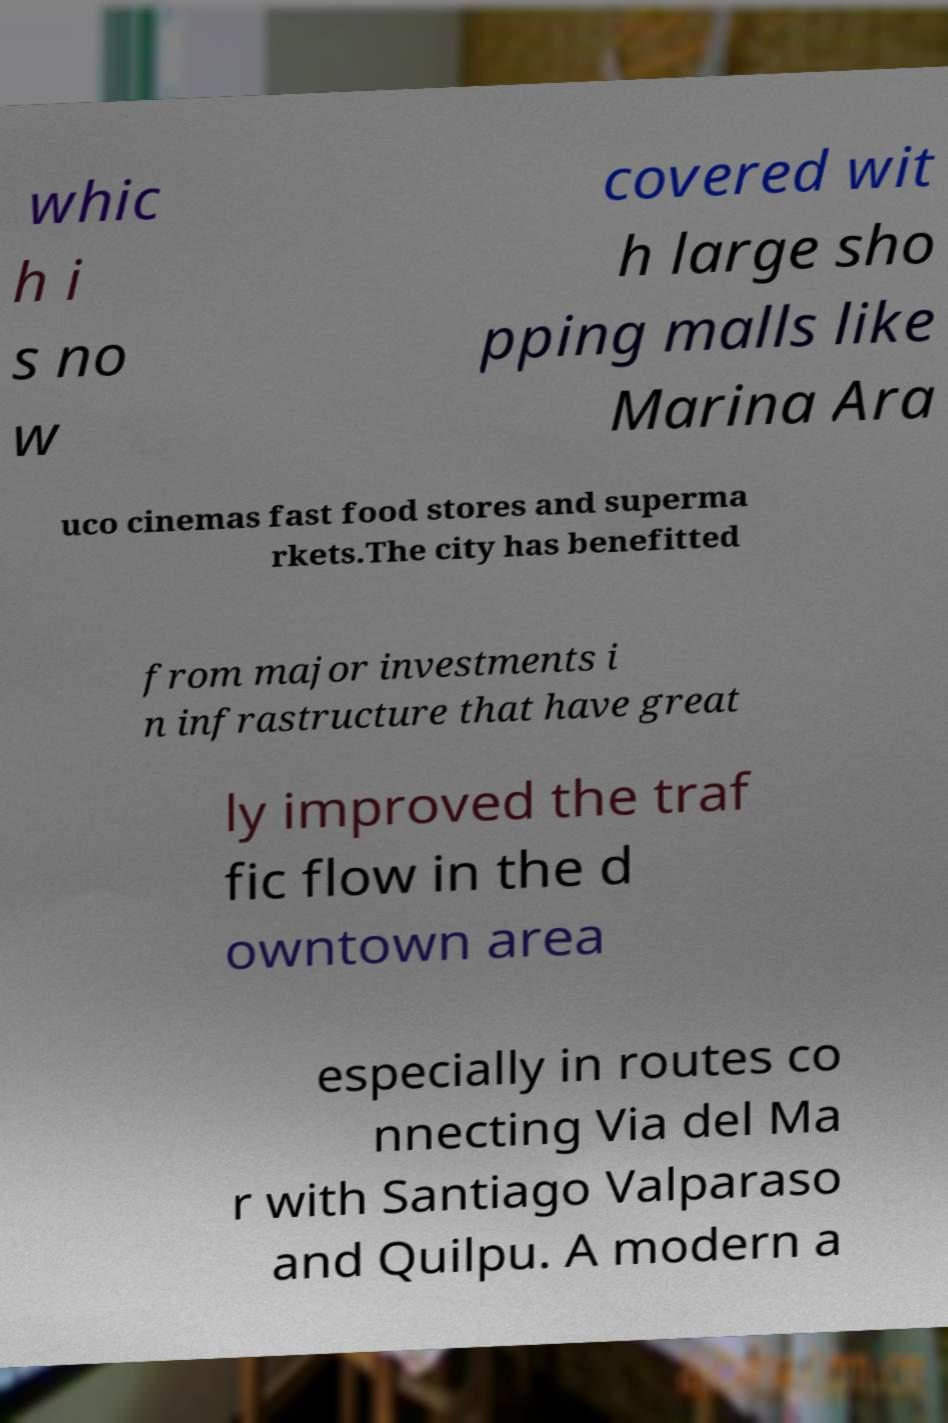Can you read and provide the text displayed in the image?This photo seems to have some interesting text. Can you extract and type it out for me? whic h i s no w covered wit h large sho pping malls like Marina Ara uco cinemas fast food stores and superma rkets.The city has benefitted from major investments i n infrastructure that have great ly improved the traf fic flow in the d owntown area especially in routes co nnecting Via del Ma r with Santiago Valparaso and Quilpu. A modern a 